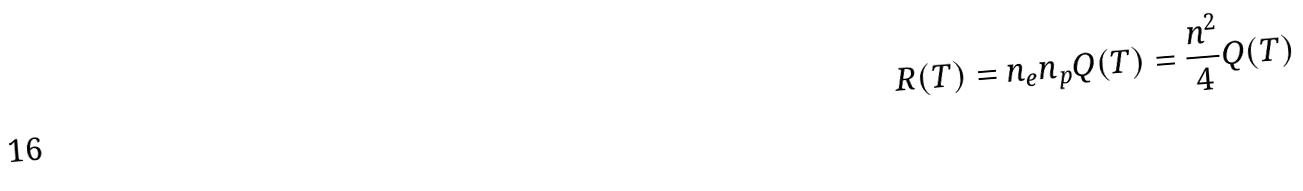<formula> <loc_0><loc_0><loc_500><loc_500>R ( T ) = n _ { e } n _ { p } Q ( T ) = \frac { n ^ { 2 } } { 4 } Q ( T )</formula> 